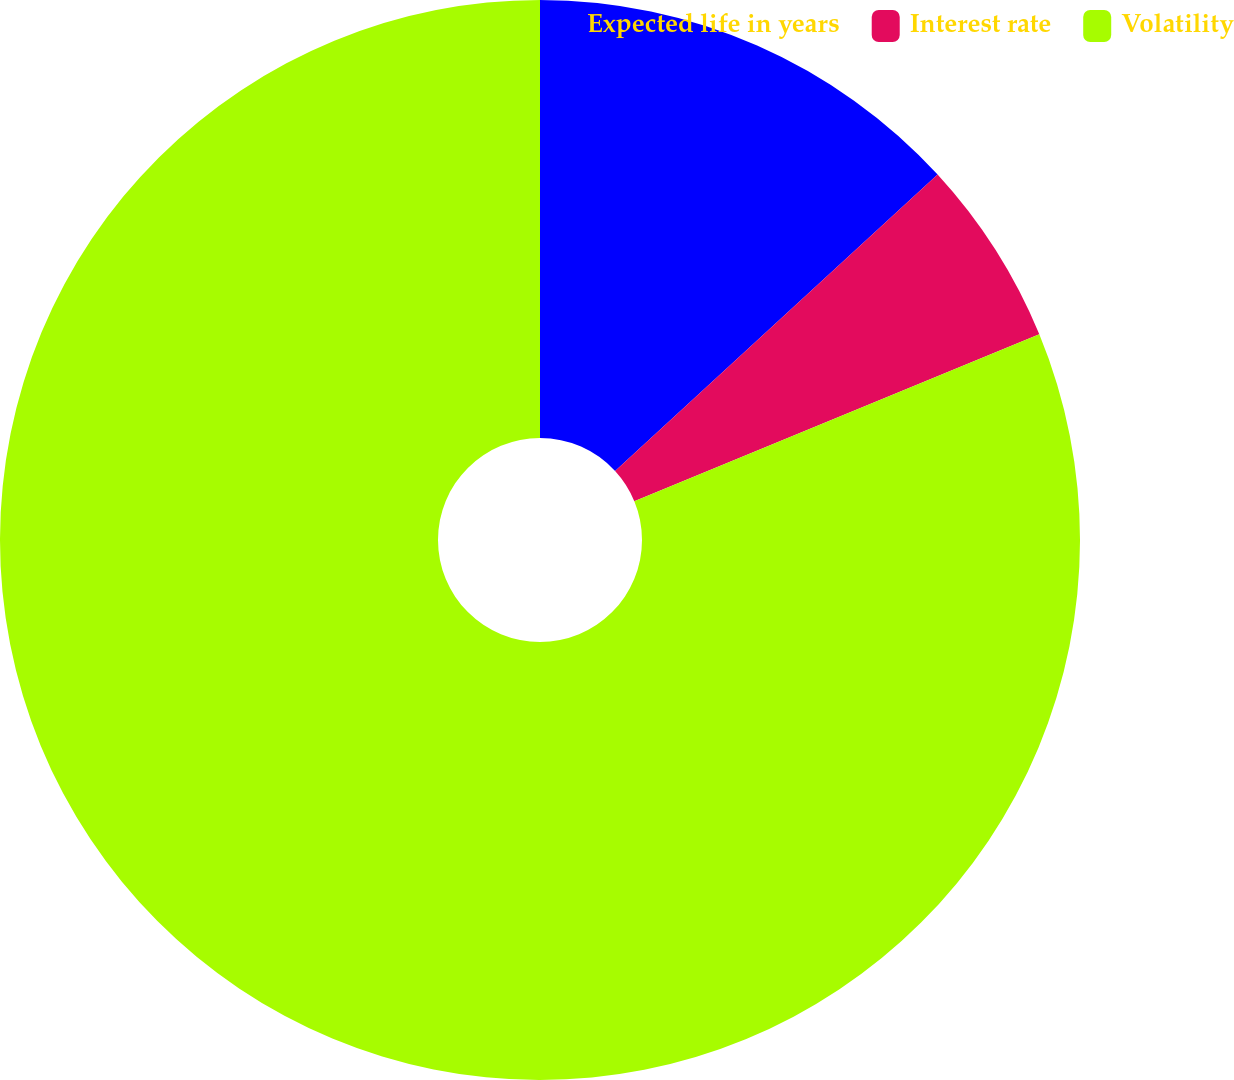Convert chart to OTSL. <chart><loc_0><loc_0><loc_500><loc_500><pie_chart><fcel>Expected life in years<fcel>Interest rate<fcel>Volatility<nl><fcel>13.17%<fcel>5.61%<fcel>81.21%<nl></chart> 